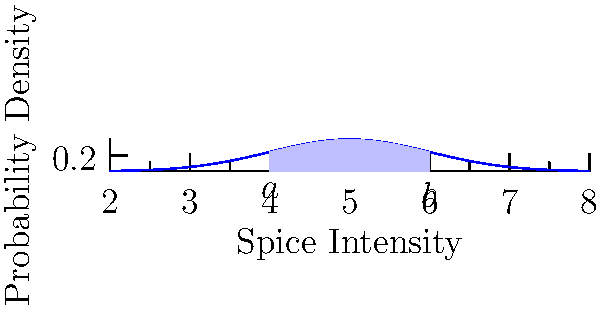As a personal chef specializing in holiday treats, you've baked a batch of gingerbread cookies. The spice intensity in these cookies follows a normal distribution with a mean of 5 and a standard deviation of 1 on a scale from 0 to 10. Calculate the probability that a randomly selected cookie will have a spice intensity between 4 and 6. To solve this problem, we need to calculate the area under the normal distribution curve between 4 and 6. We'll use the standard normal distribution (z-score) method:

1) The z-score formula is: $z = \frac{x - \mu}{\sigma}$
   Where $x$ is the value, $\mu$ is the mean, and $\sigma$ is the standard deviation.

2) Calculate z-scores for the boundaries:
   For x = 4: $z_1 = \frac{4 - 5}{1} = -1$
   For x = 6: $z_2 = \frac{6 - 5}{1} = 1$

3) The probability is the area between these z-scores on a standard normal distribution.
   This can be calculated using the cumulative distribution function (CDF) of the standard normal distribution, often denoted as $\Phi(z)$.

4) The probability is: $P(4 < X < 6) = \Phi(z_2) - \Phi(z_1) = \Phi(1) - \Phi(-1)$

5) From standard normal distribution tables or a calculator:
   $\Phi(1) \approx 0.8413$ and $\Phi(-1) \approx 0.1587$

6) Therefore, $P(4 < X < 6) = 0.8413 - 0.1587 = 0.6826$

This means there's approximately a 68.26% chance that a randomly selected cookie will have a spice intensity between 4 and 6.
Answer: 0.6826 or 68.26% 